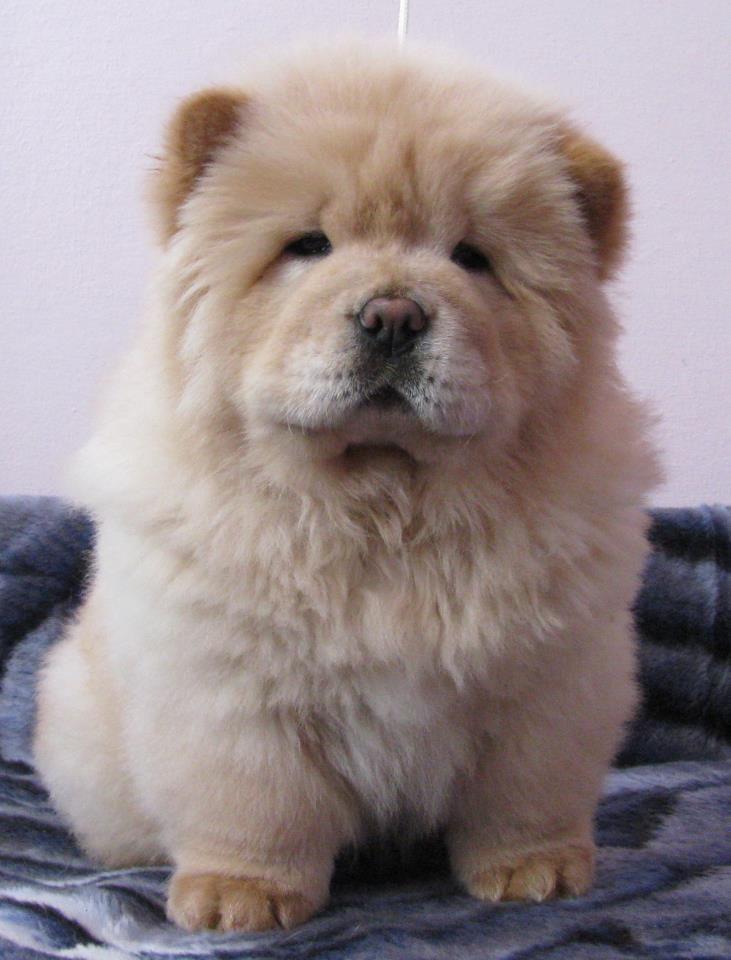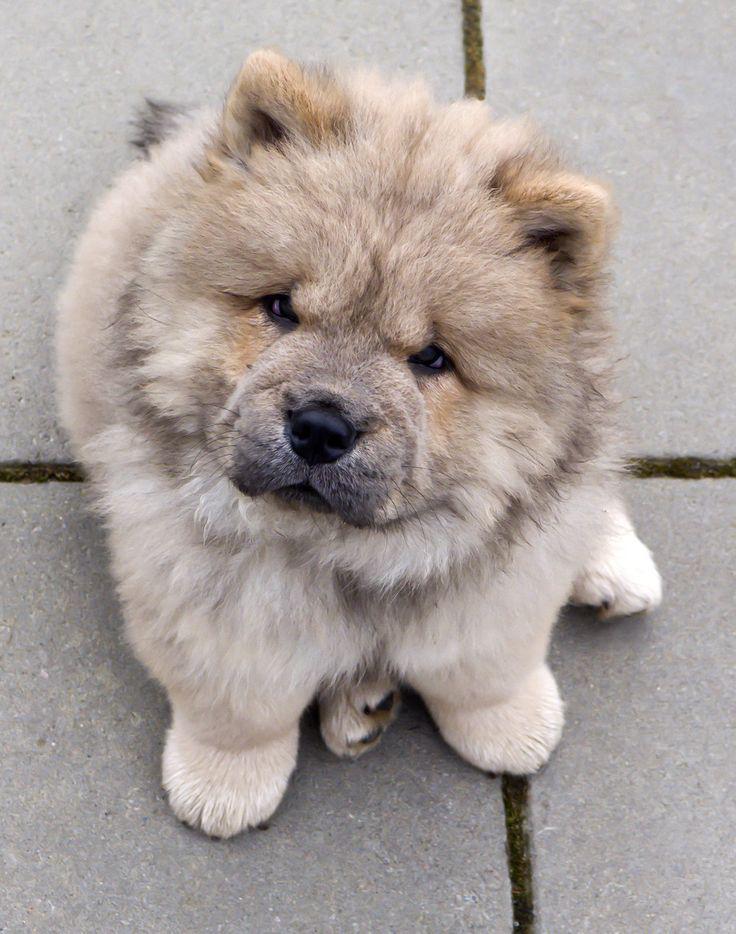The first image is the image on the left, the second image is the image on the right. Considering the images on both sides, is "Each image contains exactly one chow pup, and the pup that has darker, non-blond fur is standing on all fours." valid? Answer yes or no. No. The first image is the image on the left, the second image is the image on the right. Evaluate the accuracy of this statement regarding the images: "One of the images features a dog laying down.". Is it true? Answer yes or no. No. 